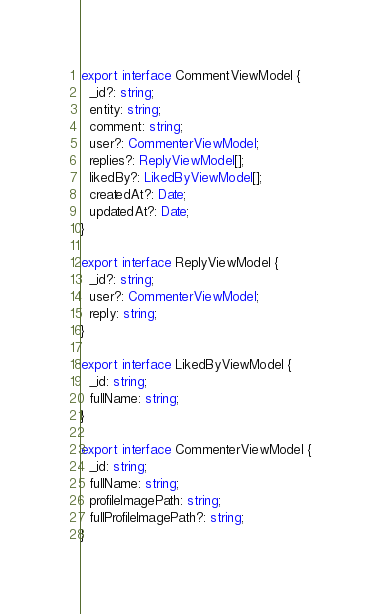Convert code to text. <code><loc_0><loc_0><loc_500><loc_500><_TypeScript_>export interface CommentViewModel {
  _id?: string;
  entity: string;
  comment: string;
  user?: CommenterViewModel;
  replies?: ReplyViewModel[];
  likedBy?: LikedByViewModel[];
  createdAt?: Date;
  updatedAt?: Date;
}

export interface ReplyViewModel {
  _id?: string;
  user?: CommenterViewModel;
  reply: string;
}

export interface LikedByViewModel {
  _id: string;
  fullName: string;
}

export interface CommenterViewModel {
  _id: string;
  fullName: string;
  profileImagePath: string;
  fullProfileImagePath?: string;
}
</code> 